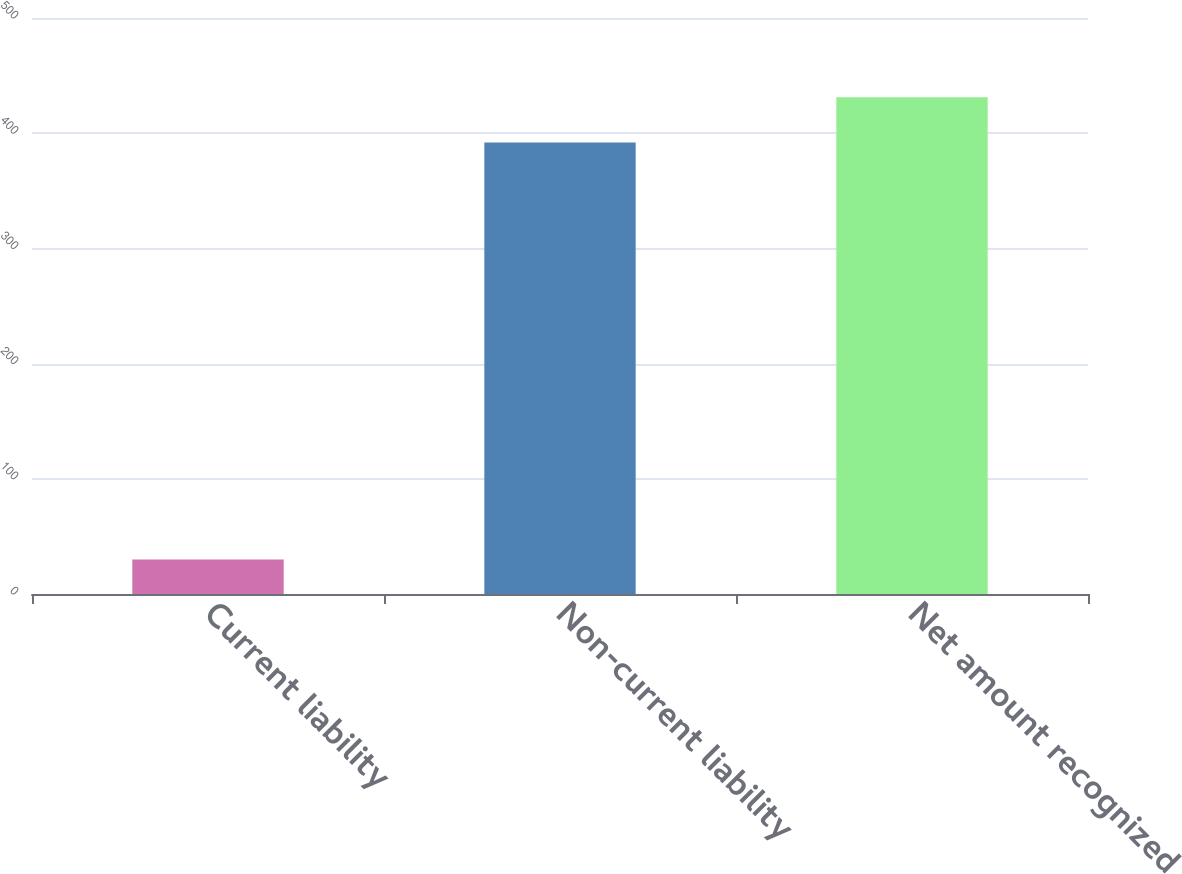Convert chart. <chart><loc_0><loc_0><loc_500><loc_500><bar_chart><fcel>Current liability<fcel>Non-current liability<fcel>Net amount recognized<nl><fcel>30<fcel>392<fcel>431.2<nl></chart> 